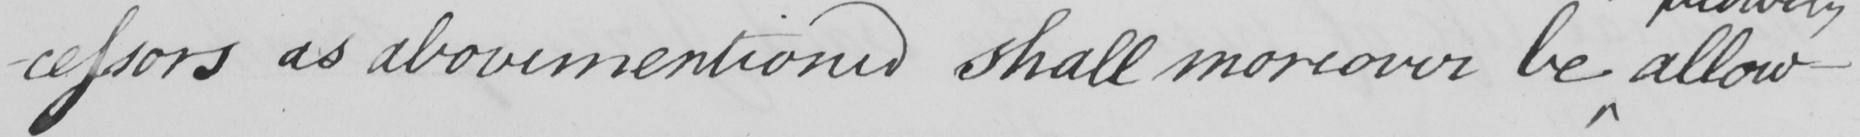Can you read and transcribe this handwriting? -cessors as abovementoned shall moreover be allowe- 